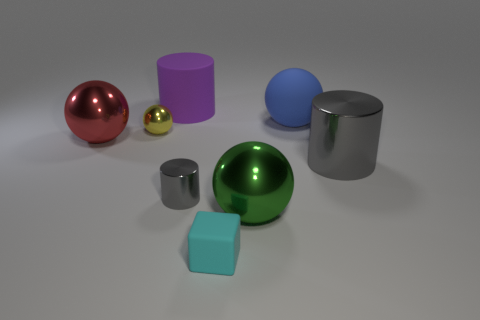Add 1 big purple things. How many objects exist? 9 Subtract all cylinders. How many objects are left? 5 Subtract all small gray metal cylinders. Subtract all matte balls. How many objects are left? 6 Add 7 big gray metal cylinders. How many big gray metal cylinders are left? 8 Add 1 purple rubber cylinders. How many purple rubber cylinders exist? 2 Subtract 0 brown spheres. How many objects are left? 8 